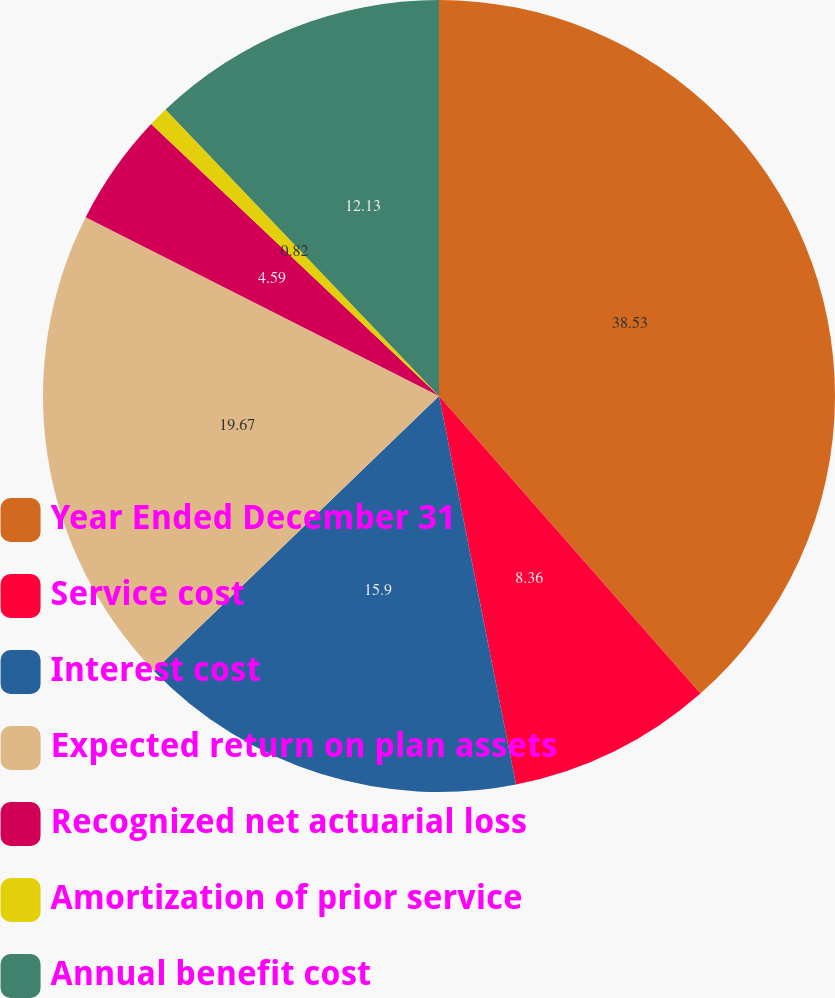Convert chart. <chart><loc_0><loc_0><loc_500><loc_500><pie_chart><fcel>Year Ended December 31<fcel>Service cost<fcel>Interest cost<fcel>Expected return on plan assets<fcel>Recognized net actuarial loss<fcel>Amortization of prior service<fcel>Annual benefit cost<nl><fcel>38.52%<fcel>8.36%<fcel>15.9%<fcel>19.67%<fcel>4.59%<fcel>0.82%<fcel>12.13%<nl></chart> 